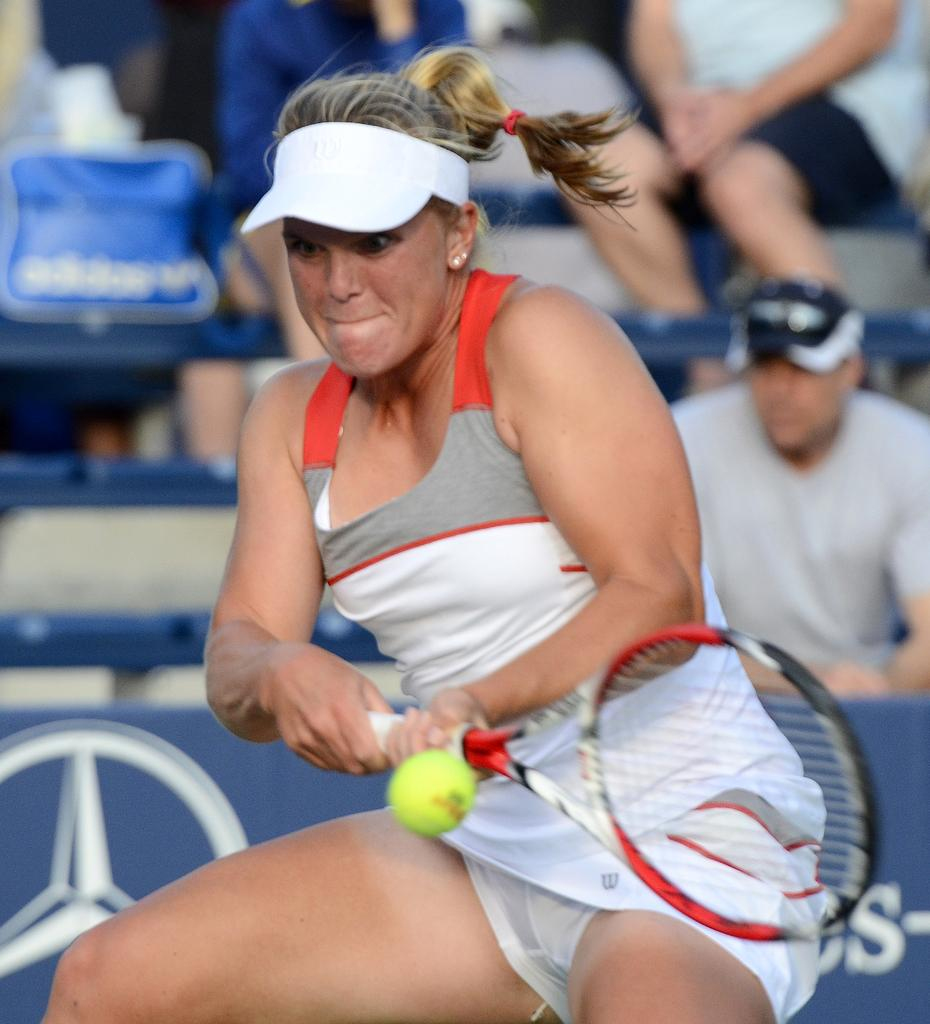Who is the main subject in the image? There is a woman in the image. What is the woman holding in the image? The woman is holding a bat. What is the woman doing with the bat? The woman is hitting a ball. What type of goat can be seen in the image? There is no goat present in the image. What time of day is it in the image? The time of day cannot be determined from the image. 